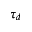Convert formula to latex. <formula><loc_0><loc_0><loc_500><loc_500>\tau _ { d }</formula> 